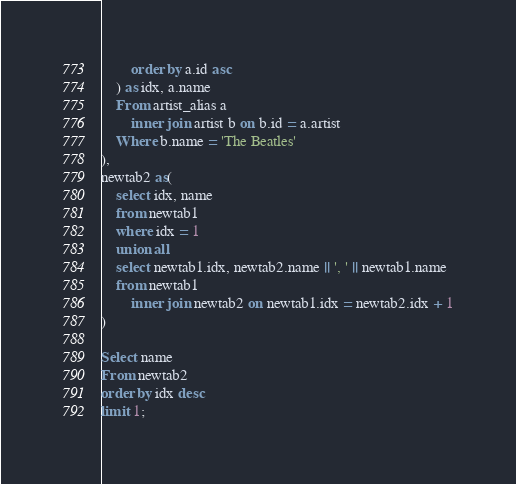<code> <loc_0><loc_0><loc_500><loc_500><_SQL_>		order by a.id asc	
	) as idx, a.name
	From artist_alias a
		inner join artist b on b.id = a.artist
	Where b.name = 'The Beatles'
),
newtab2 as(
	select idx, name
	from newtab1
	where idx = 1
	union all
	select newtab1.idx, newtab2.name || ', ' || newtab1.name
	from newtab1
		inner join newtab2 on newtab1.idx = newtab2.idx + 1
)

Select name 
From newtab2
order by idx desc
limit 1;
</code> 